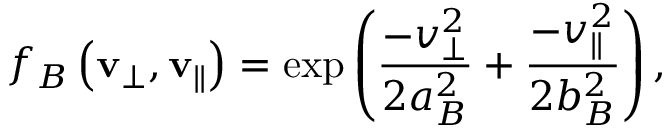<formula> <loc_0><loc_0><loc_500><loc_500>f _ { B } \left ( v _ { \perp } , v _ { \| } \right ) = \exp \left ( \frac { - v _ { \perp } ^ { 2 } } { 2 a _ { B } ^ { 2 } } + \frac { - v _ { \| } ^ { 2 } } { 2 b _ { B } ^ { 2 } } \right ) ,</formula> 